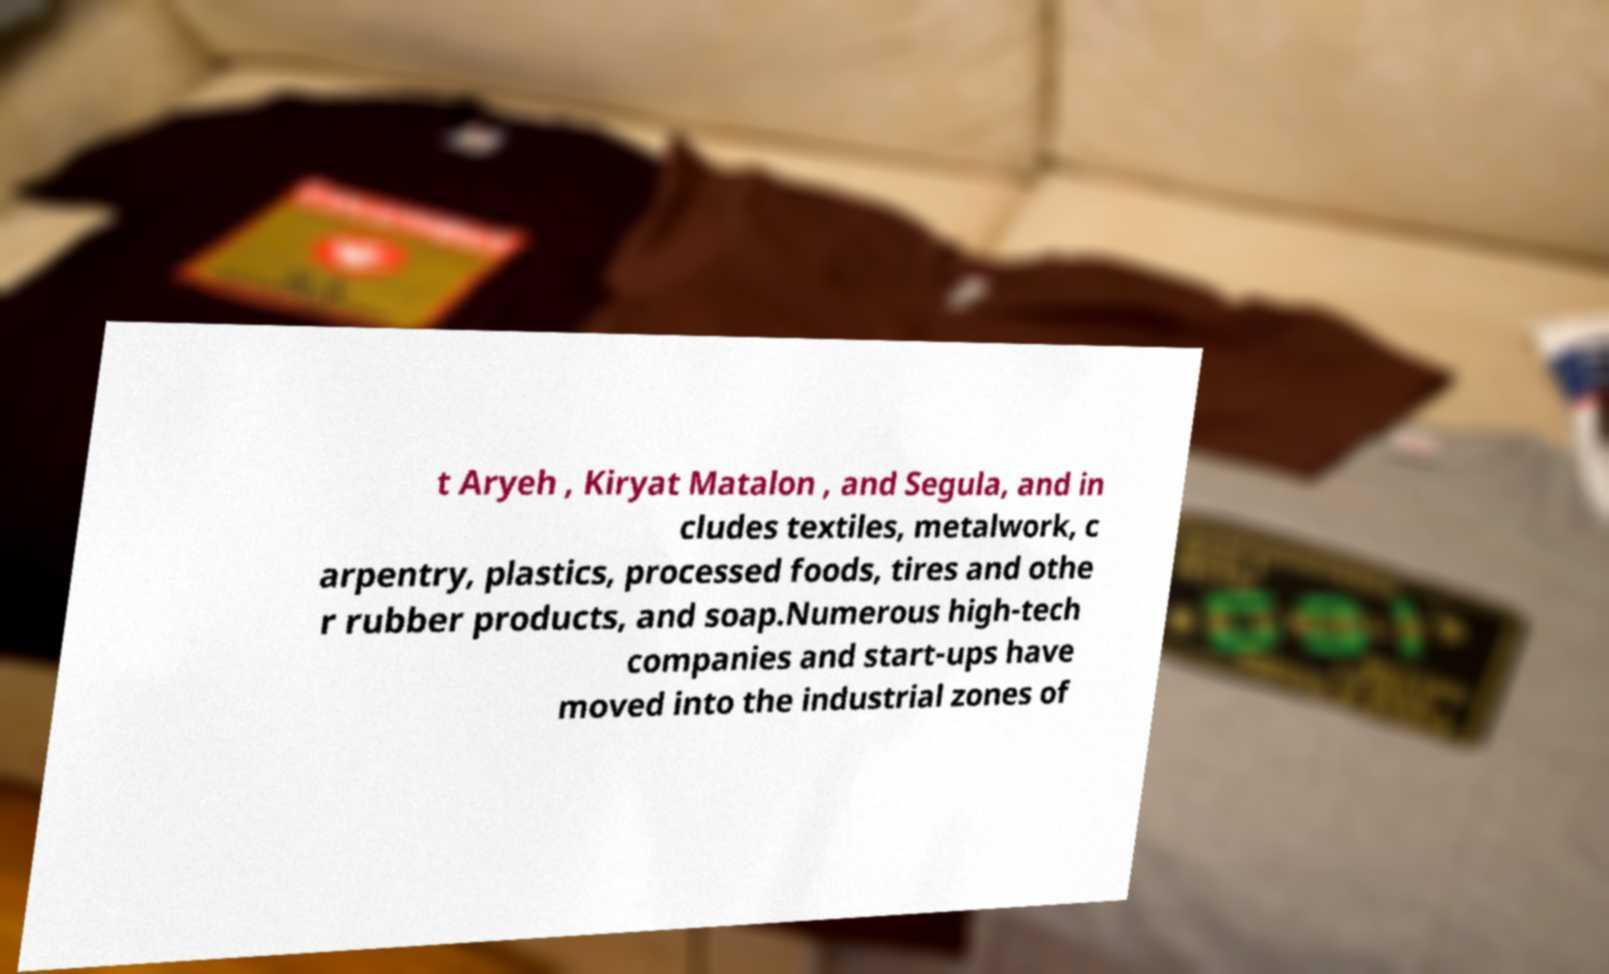Can you accurately transcribe the text from the provided image for me? t Aryeh , Kiryat Matalon , and Segula, and in cludes textiles, metalwork, c arpentry, plastics, processed foods, tires and othe r rubber products, and soap.Numerous high-tech companies and start-ups have moved into the industrial zones of 